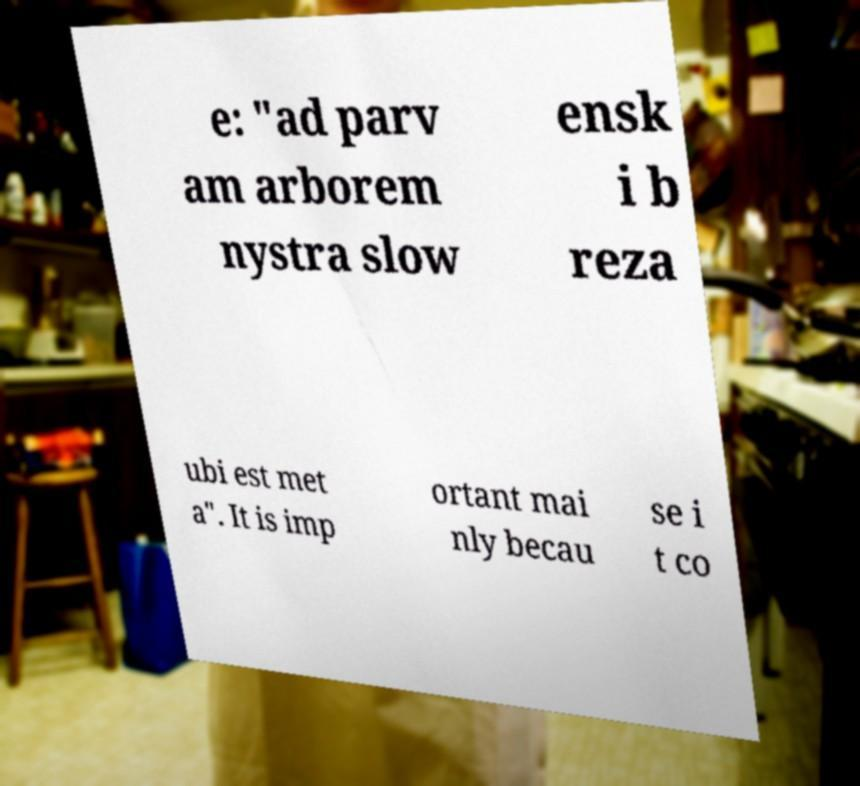There's text embedded in this image that I need extracted. Can you transcribe it verbatim? e: "ad parv am arborem nystra slow ensk i b reza ubi est met a". It is imp ortant mai nly becau se i t co 